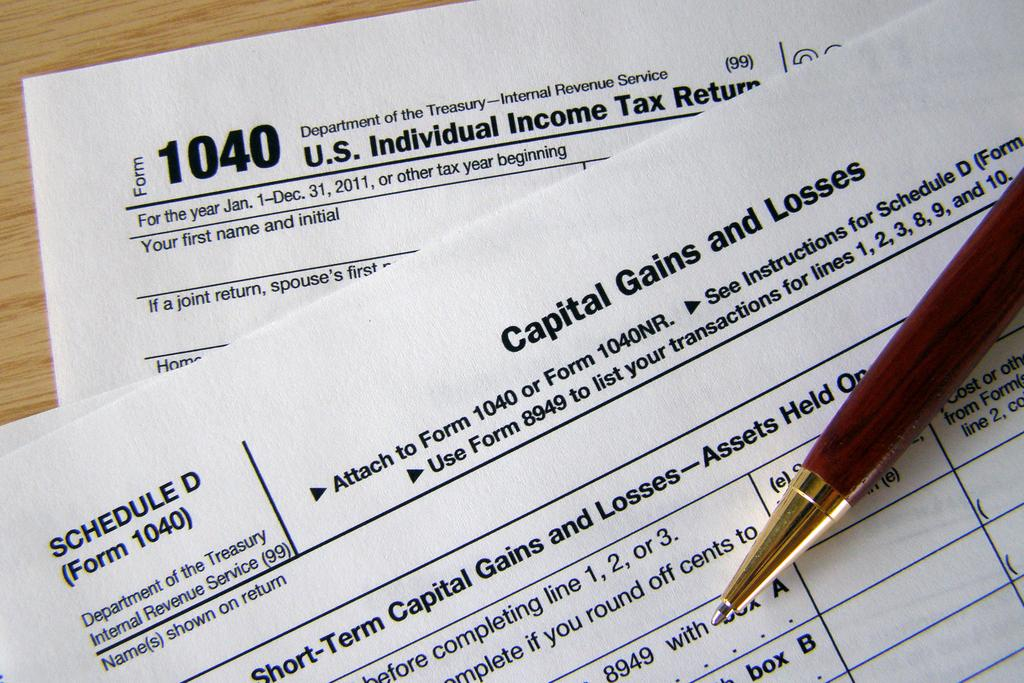What stationery item can be seen in the image? There is a pen in the image. What is the pen placed on or near in the image? The wooden surface is present in the image. What might the pen be used for in the image? The pen might be used for writing or drawing on the papers in the image. Is there a wound visible on the pen in the image? No, there is no wound visible on the pen in the image. Can you see a kettle boiling in the background of the image? No, there is no kettle present in the image. 